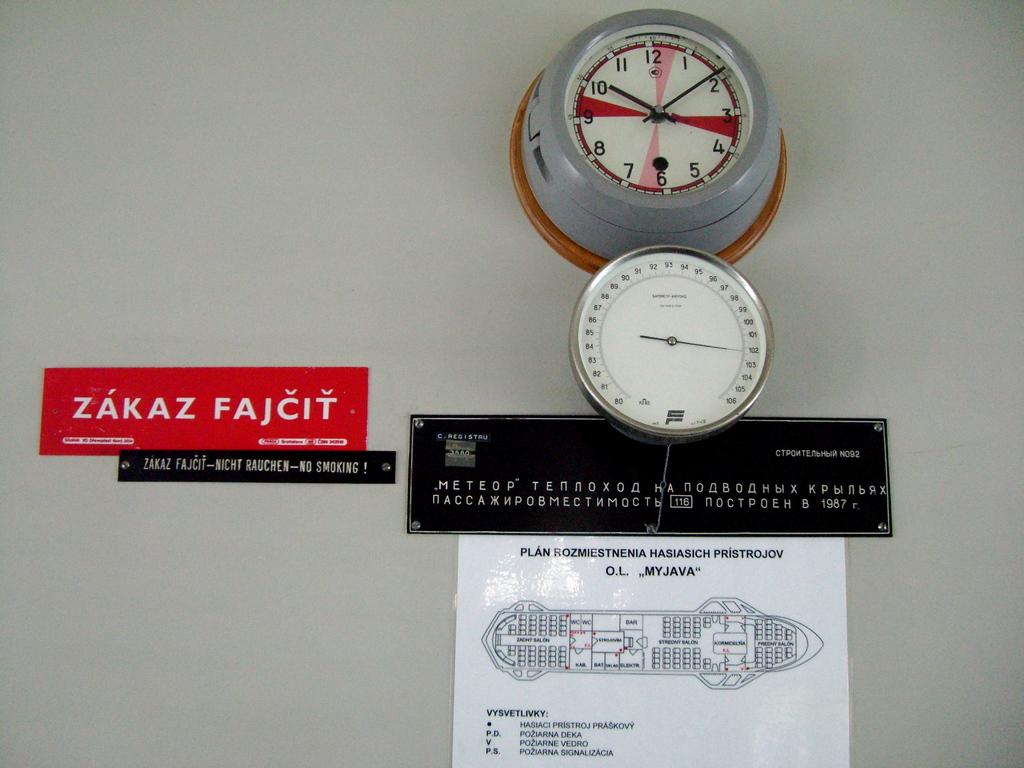Are the hands on the gauge in the red?
Offer a terse response. Answering does not require reading text in the image. What time is it?
Your response must be concise. 10:09. 